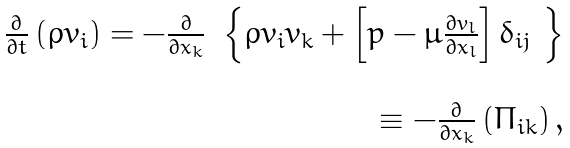<formula> <loc_0><loc_0><loc_500><loc_500>\begin{array} { r } \frac { \partial } { \partial t } \left ( \rho v _ { i } \right ) = - \frac { \partial } { \partial x _ { k } } \ \left \{ \rho v _ { i } v _ { k } + \left [ p - \mu \frac { \partial v _ { l } } { \partial x _ { l } } \right ] \delta _ { i j } \ \right \} \\ \\ \equiv - \frac { \partial } { \partial x _ { k } } \left ( \Pi _ { i k } \right ) , \end{array}</formula> 